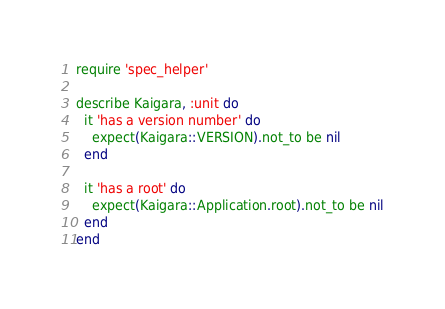<code> <loc_0><loc_0><loc_500><loc_500><_Ruby_>require 'spec_helper'

describe Kaigara, :unit do
  it 'has a version number' do
    expect(Kaigara::VERSION).not_to be nil
  end

  it 'has a root' do
    expect(Kaigara::Application.root).not_to be nil
  end
end
</code> 